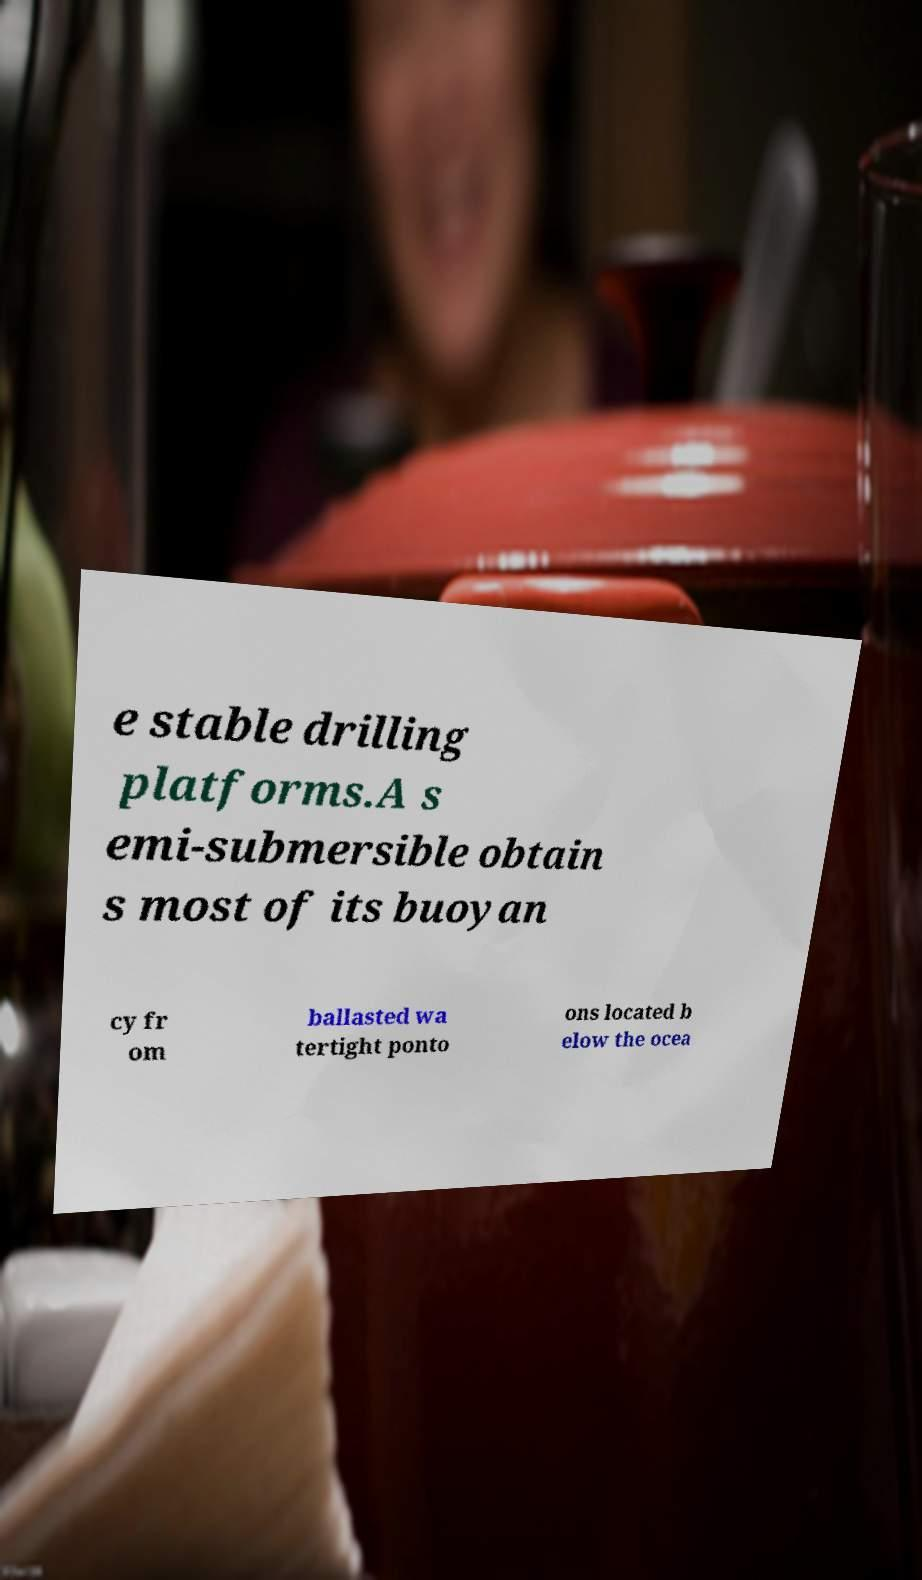I need the written content from this picture converted into text. Can you do that? e stable drilling platforms.A s emi-submersible obtain s most of its buoyan cy fr om ballasted wa tertight ponto ons located b elow the ocea 